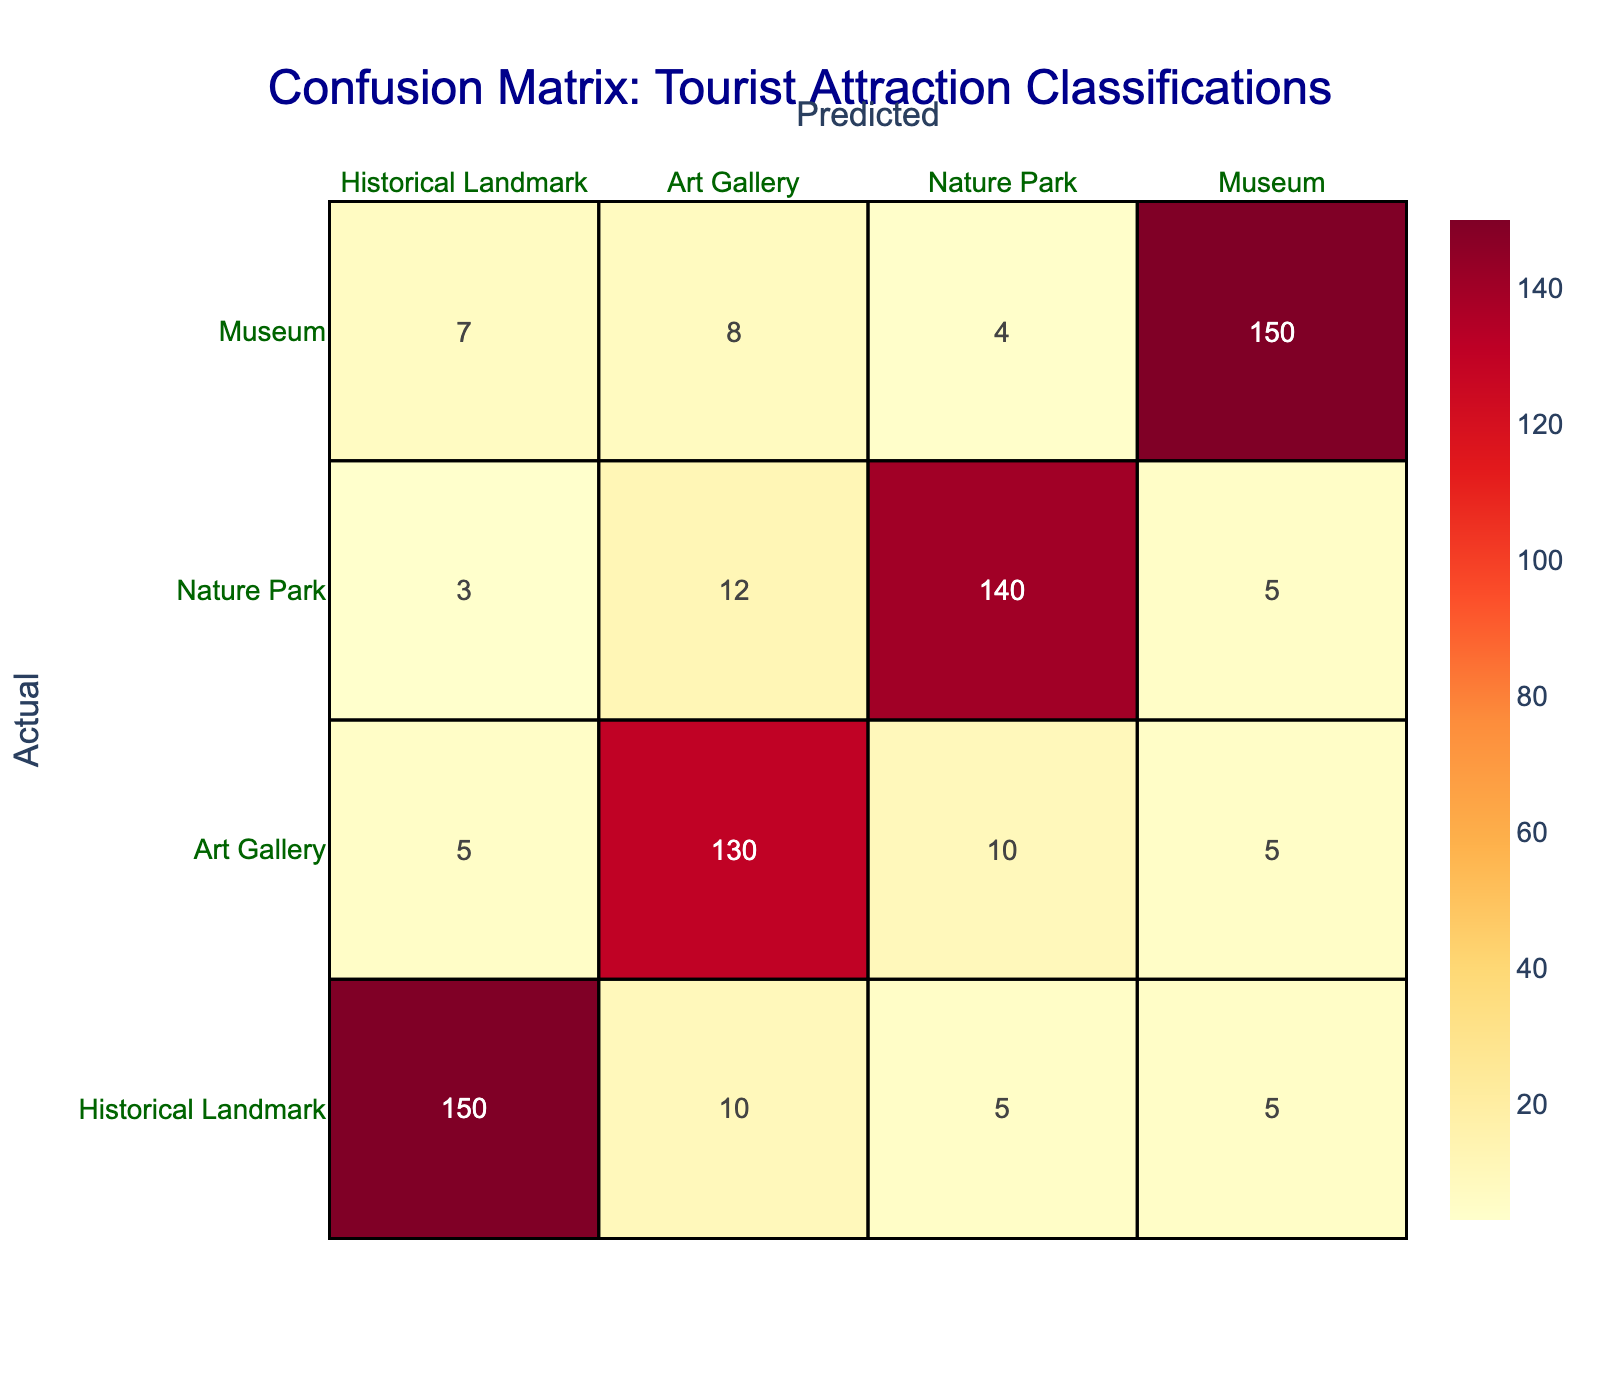What is the total number of correctly classified Historical Landmarks? The number of correctly classified Historical Landmarks corresponds to the value in the intersection of the Historical Landmark row and the Historical Landmark column, which is 150.
Answer: 150 How many total classifications were made for Art Galleries? To find the total classifications for Art Galleries, we sum the values in the Art Gallery column: 5 (Historical Landmark) + 130 (Art Gallery) + 10 (Nature Park) + 5 (Museum) = 150.
Answer: 150 Is it true that the Museum was more often misclassified as an Art Gallery than as a Nature Park? The Museum was classified as an Art Gallery 8 times, while it was classified as a Nature Park 4 times. Since 8 is greater than 4, it is true that there were more misclassifications as an Art Gallery.
Answer: Yes What is the combined total of misclassifications for Nature Parks? The misclassifications for Nature Parks can be obtained by adding the values in the Nature Park row excluding the correctly classified count: 3 (Historical Landmark) + 12 (Art Gallery) + 5 (Museum) = 20.
Answer: 20 What percentage of the total classifications were correctly identified as Museums? The total number of classifications is found by summing all values in the confusion matrix: 150 + 10 + 5 + 5 + 5 + 130 + 10 + 5 + 3 + 12 + 140 + 5 + 7 + 8 + 4 + 150 =  493. The correctly identified Museums count is 150. The percentage is calculated as (150 / 493) * 100 ≈ 30.4%.
Answer: 30.4% How many misclassifications occurred for Historical Landmarks compared to correctly classified ones? The number of misclassifications for Historical Landmarks is 10 (as Art Gallery) + 5 (as Nature Park) + 5 (as Museum) = 20. Therefore, compared to 150 correct classifications, there were 20 misclassifications.
Answer: 20 Which tourist attraction type was misclassified as Nature Parks the most? The highest number in the Nature Park column (which represents how other types were misclassified as Nature Parks) is 12, which belongs to the Art Gallery. Therefore, Art Galleries were misclassified as Nature Parks the most.
Answer: Art Gallery What is the difference between the number of correct classifications of Museums and Historical Landmarks? The number of correct classifications is 150 for Historical Landmarks and 150 for Museums. The difference is calculated as 150 - 150 = 0.
Answer: 0 